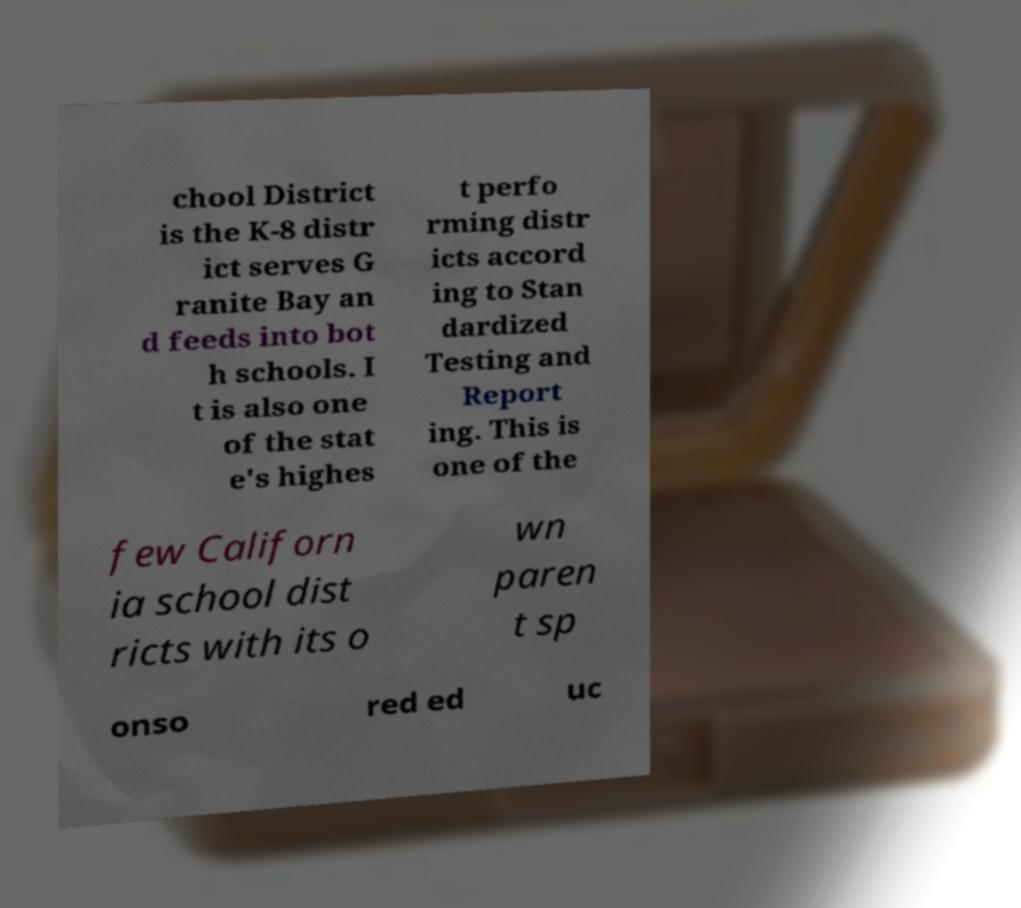Can you read and provide the text displayed in the image?This photo seems to have some interesting text. Can you extract and type it out for me? chool District is the K-8 distr ict serves G ranite Bay an d feeds into bot h schools. I t is also one of the stat e's highes t perfo rming distr icts accord ing to Stan dardized Testing and Report ing. This is one of the few Californ ia school dist ricts with its o wn paren t sp onso red ed uc 